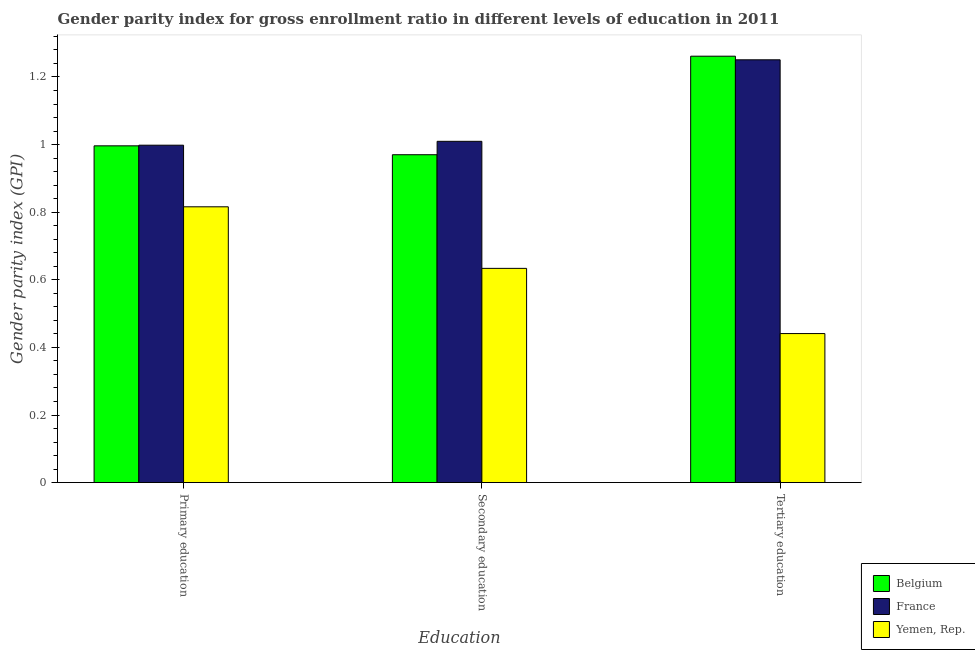How many groups of bars are there?
Your answer should be compact. 3. Are the number of bars on each tick of the X-axis equal?
Your response must be concise. Yes. How many bars are there on the 3rd tick from the left?
Offer a terse response. 3. What is the label of the 3rd group of bars from the left?
Give a very brief answer. Tertiary education. What is the gender parity index in tertiary education in Belgium?
Offer a terse response. 1.26. Across all countries, what is the maximum gender parity index in tertiary education?
Give a very brief answer. 1.26. Across all countries, what is the minimum gender parity index in tertiary education?
Provide a succinct answer. 0.44. In which country was the gender parity index in secondary education maximum?
Provide a succinct answer. France. In which country was the gender parity index in tertiary education minimum?
Provide a short and direct response. Yemen, Rep. What is the total gender parity index in tertiary education in the graph?
Keep it short and to the point. 2.95. What is the difference between the gender parity index in primary education in France and that in Yemen, Rep.?
Your answer should be very brief. 0.18. What is the difference between the gender parity index in secondary education in Yemen, Rep. and the gender parity index in tertiary education in France?
Your answer should be compact. -0.62. What is the average gender parity index in tertiary education per country?
Your answer should be compact. 0.98. What is the difference between the gender parity index in primary education and gender parity index in tertiary education in Belgium?
Your answer should be compact. -0.27. In how many countries, is the gender parity index in secondary education greater than 0.8 ?
Your answer should be very brief. 2. What is the ratio of the gender parity index in tertiary education in Yemen, Rep. to that in France?
Make the answer very short. 0.35. Is the gender parity index in tertiary education in France less than that in Yemen, Rep.?
Your answer should be very brief. No. What is the difference between the highest and the second highest gender parity index in primary education?
Provide a short and direct response. 0. What is the difference between the highest and the lowest gender parity index in secondary education?
Ensure brevity in your answer.  0.38. In how many countries, is the gender parity index in tertiary education greater than the average gender parity index in tertiary education taken over all countries?
Your answer should be very brief. 2. Is the sum of the gender parity index in tertiary education in France and Belgium greater than the maximum gender parity index in primary education across all countries?
Make the answer very short. Yes. What does the 3rd bar from the left in Tertiary education represents?
Give a very brief answer. Yemen, Rep. What does the 1st bar from the right in Secondary education represents?
Your answer should be very brief. Yemen, Rep. Is it the case that in every country, the sum of the gender parity index in primary education and gender parity index in secondary education is greater than the gender parity index in tertiary education?
Offer a very short reply. Yes. How many bars are there?
Your answer should be very brief. 9. Are all the bars in the graph horizontal?
Make the answer very short. No. How many countries are there in the graph?
Provide a succinct answer. 3. What is the difference between two consecutive major ticks on the Y-axis?
Offer a very short reply. 0.2. Are the values on the major ticks of Y-axis written in scientific E-notation?
Your answer should be very brief. No. Where does the legend appear in the graph?
Your response must be concise. Bottom right. What is the title of the graph?
Your answer should be compact. Gender parity index for gross enrollment ratio in different levels of education in 2011. Does "High income: nonOECD" appear as one of the legend labels in the graph?
Provide a short and direct response. No. What is the label or title of the X-axis?
Make the answer very short. Education. What is the label or title of the Y-axis?
Offer a very short reply. Gender parity index (GPI). What is the Gender parity index (GPI) in Belgium in Primary education?
Your answer should be compact. 1. What is the Gender parity index (GPI) in France in Primary education?
Offer a terse response. 1. What is the Gender parity index (GPI) in Yemen, Rep. in Primary education?
Your answer should be very brief. 0.82. What is the Gender parity index (GPI) in Belgium in Secondary education?
Offer a terse response. 0.97. What is the Gender parity index (GPI) in France in Secondary education?
Provide a short and direct response. 1.01. What is the Gender parity index (GPI) of Yemen, Rep. in Secondary education?
Your answer should be very brief. 0.63. What is the Gender parity index (GPI) of Belgium in Tertiary education?
Your answer should be compact. 1.26. What is the Gender parity index (GPI) of France in Tertiary education?
Provide a succinct answer. 1.25. What is the Gender parity index (GPI) of Yemen, Rep. in Tertiary education?
Your response must be concise. 0.44. Across all Education, what is the maximum Gender parity index (GPI) in Belgium?
Keep it short and to the point. 1.26. Across all Education, what is the maximum Gender parity index (GPI) of France?
Give a very brief answer. 1.25. Across all Education, what is the maximum Gender parity index (GPI) in Yemen, Rep.?
Provide a succinct answer. 0.82. Across all Education, what is the minimum Gender parity index (GPI) of Belgium?
Provide a succinct answer. 0.97. Across all Education, what is the minimum Gender parity index (GPI) of France?
Give a very brief answer. 1. Across all Education, what is the minimum Gender parity index (GPI) of Yemen, Rep.?
Your answer should be very brief. 0.44. What is the total Gender parity index (GPI) in Belgium in the graph?
Provide a short and direct response. 3.23. What is the total Gender parity index (GPI) in France in the graph?
Offer a terse response. 3.26. What is the total Gender parity index (GPI) of Yemen, Rep. in the graph?
Your answer should be compact. 1.89. What is the difference between the Gender parity index (GPI) in Belgium in Primary education and that in Secondary education?
Provide a succinct answer. 0.03. What is the difference between the Gender parity index (GPI) of France in Primary education and that in Secondary education?
Provide a succinct answer. -0.01. What is the difference between the Gender parity index (GPI) of Yemen, Rep. in Primary education and that in Secondary education?
Your response must be concise. 0.18. What is the difference between the Gender parity index (GPI) of Belgium in Primary education and that in Tertiary education?
Give a very brief answer. -0.27. What is the difference between the Gender parity index (GPI) of France in Primary education and that in Tertiary education?
Give a very brief answer. -0.25. What is the difference between the Gender parity index (GPI) in Yemen, Rep. in Primary education and that in Tertiary education?
Your response must be concise. 0.38. What is the difference between the Gender parity index (GPI) of Belgium in Secondary education and that in Tertiary education?
Provide a short and direct response. -0.29. What is the difference between the Gender parity index (GPI) in France in Secondary education and that in Tertiary education?
Make the answer very short. -0.24. What is the difference between the Gender parity index (GPI) of Yemen, Rep. in Secondary education and that in Tertiary education?
Keep it short and to the point. 0.19. What is the difference between the Gender parity index (GPI) of Belgium in Primary education and the Gender parity index (GPI) of France in Secondary education?
Your answer should be very brief. -0.01. What is the difference between the Gender parity index (GPI) in Belgium in Primary education and the Gender parity index (GPI) in Yemen, Rep. in Secondary education?
Provide a short and direct response. 0.36. What is the difference between the Gender parity index (GPI) in France in Primary education and the Gender parity index (GPI) in Yemen, Rep. in Secondary education?
Your answer should be very brief. 0.36. What is the difference between the Gender parity index (GPI) in Belgium in Primary education and the Gender parity index (GPI) in France in Tertiary education?
Your response must be concise. -0.25. What is the difference between the Gender parity index (GPI) of Belgium in Primary education and the Gender parity index (GPI) of Yemen, Rep. in Tertiary education?
Offer a terse response. 0.56. What is the difference between the Gender parity index (GPI) of France in Primary education and the Gender parity index (GPI) of Yemen, Rep. in Tertiary education?
Give a very brief answer. 0.56. What is the difference between the Gender parity index (GPI) in Belgium in Secondary education and the Gender parity index (GPI) in France in Tertiary education?
Your response must be concise. -0.28. What is the difference between the Gender parity index (GPI) of Belgium in Secondary education and the Gender parity index (GPI) of Yemen, Rep. in Tertiary education?
Your answer should be compact. 0.53. What is the difference between the Gender parity index (GPI) in France in Secondary education and the Gender parity index (GPI) in Yemen, Rep. in Tertiary education?
Your answer should be compact. 0.57. What is the average Gender parity index (GPI) in Belgium per Education?
Your answer should be very brief. 1.08. What is the average Gender parity index (GPI) of France per Education?
Provide a succinct answer. 1.09. What is the average Gender parity index (GPI) in Yemen, Rep. per Education?
Keep it short and to the point. 0.63. What is the difference between the Gender parity index (GPI) in Belgium and Gender parity index (GPI) in France in Primary education?
Make the answer very short. -0. What is the difference between the Gender parity index (GPI) of Belgium and Gender parity index (GPI) of Yemen, Rep. in Primary education?
Your answer should be very brief. 0.18. What is the difference between the Gender parity index (GPI) in France and Gender parity index (GPI) in Yemen, Rep. in Primary education?
Your response must be concise. 0.18. What is the difference between the Gender parity index (GPI) in Belgium and Gender parity index (GPI) in France in Secondary education?
Your response must be concise. -0.04. What is the difference between the Gender parity index (GPI) in Belgium and Gender parity index (GPI) in Yemen, Rep. in Secondary education?
Make the answer very short. 0.34. What is the difference between the Gender parity index (GPI) in France and Gender parity index (GPI) in Yemen, Rep. in Secondary education?
Provide a succinct answer. 0.38. What is the difference between the Gender parity index (GPI) in Belgium and Gender parity index (GPI) in France in Tertiary education?
Your answer should be compact. 0.01. What is the difference between the Gender parity index (GPI) in Belgium and Gender parity index (GPI) in Yemen, Rep. in Tertiary education?
Your answer should be compact. 0.82. What is the difference between the Gender parity index (GPI) in France and Gender parity index (GPI) in Yemen, Rep. in Tertiary education?
Your response must be concise. 0.81. What is the ratio of the Gender parity index (GPI) of Belgium in Primary education to that in Secondary education?
Give a very brief answer. 1.03. What is the ratio of the Gender parity index (GPI) of France in Primary education to that in Secondary education?
Offer a terse response. 0.99. What is the ratio of the Gender parity index (GPI) of Yemen, Rep. in Primary education to that in Secondary education?
Give a very brief answer. 1.29. What is the ratio of the Gender parity index (GPI) in Belgium in Primary education to that in Tertiary education?
Keep it short and to the point. 0.79. What is the ratio of the Gender parity index (GPI) in France in Primary education to that in Tertiary education?
Make the answer very short. 0.8. What is the ratio of the Gender parity index (GPI) in Yemen, Rep. in Primary education to that in Tertiary education?
Provide a succinct answer. 1.85. What is the ratio of the Gender parity index (GPI) of Belgium in Secondary education to that in Tertiary education?
Provide a succinct answer. 0.77. What is the ratio of the Gender parity index (GPI) of France in Secondary education to that in Tertiary education?
Give a very brief answer. 0.81. What is the ratio of the Gender parity index (GPI) in Yemen, Rep. in Secondary education to that in Tertiary education?
Make the answer very short. 1.44. What is the difference between the highest and the second highest Gender parity index (GPI) of Belgium?
Provide a succinct answer. 0.27. What is the difference between the highest and the second highest Gender parity index (GPI) of France?
Offer a very short reply. 0.24. What is the difference between the highest and the second highest Gender parity index (GPI) of Yemen, Rep.?
Offer a terse response. 0.18. What is the difference between the highest and the lowest Gender parity index (GPI) in Belgium?
Provide a short and direct response. 0.29. What is the difference between the highest and the lowest Gender parity index (GPI) of France?
Provide a short and direct response. 0.25. What is the difference between the highest and the lowest Gender parity index (GPI) of Yemen, Rep.?
Your response must be concise. 0.38. 